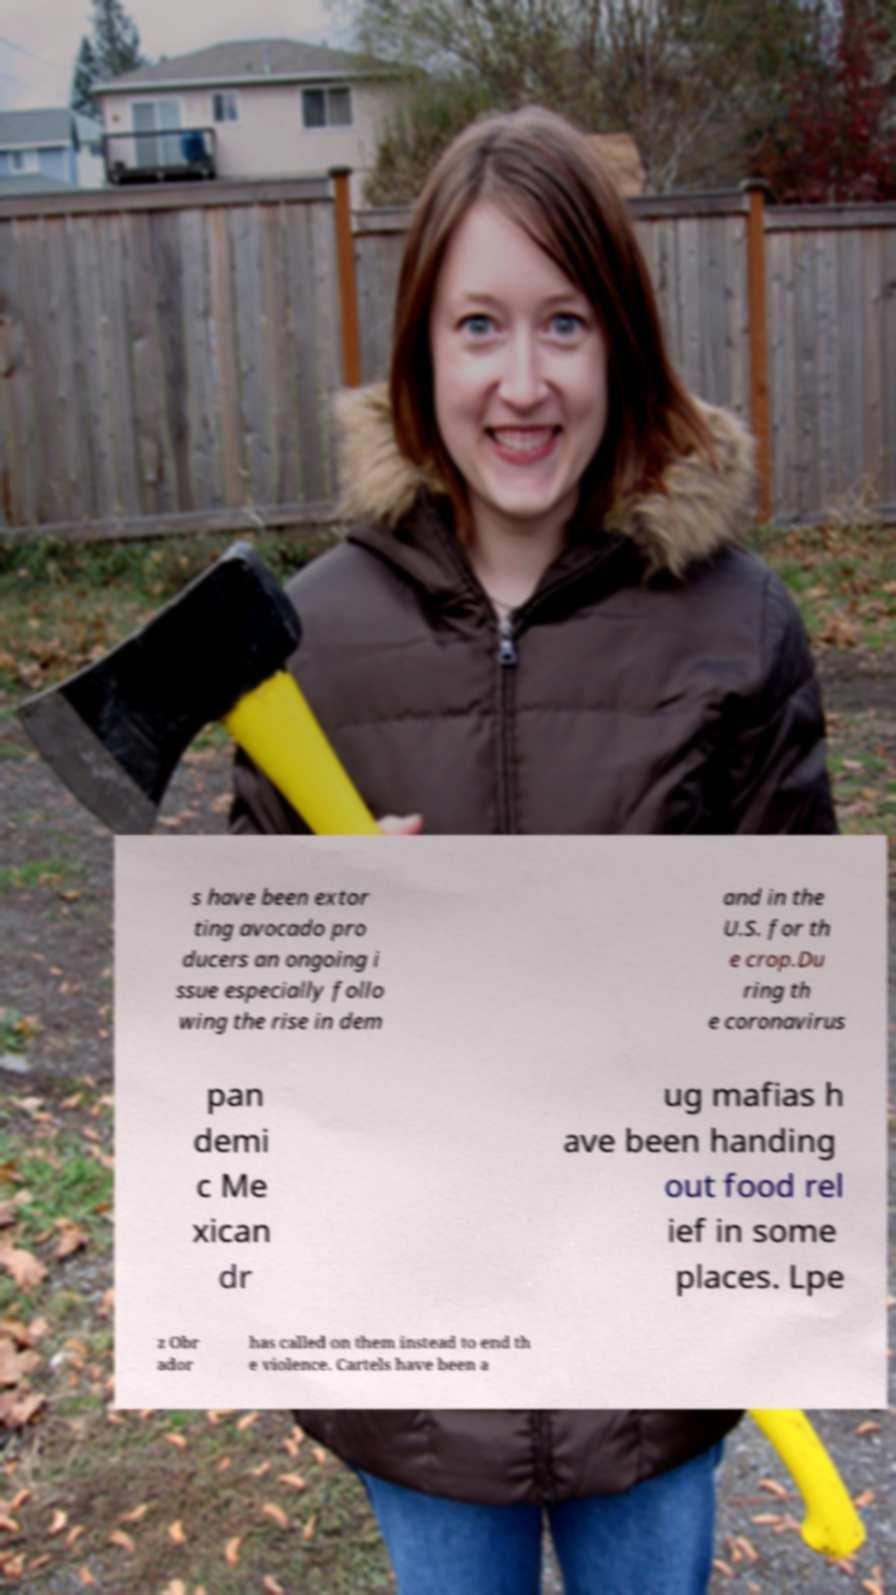Can you read and provide the text displayed in the image?This photo seems to have some interesting text. Can you extract and type it out for me? s have been extor ting avocado pro ducers an ongoing i ssue especially follo wing the rise in dem and in the U.S. for th e crop.Du ring th e coronavirus pan demi c Me xican dr ug mafias h ave been handing out food rel ief in some places. Lpe z Obr ador has called on them instead to end th e violence. Cartels have been a 